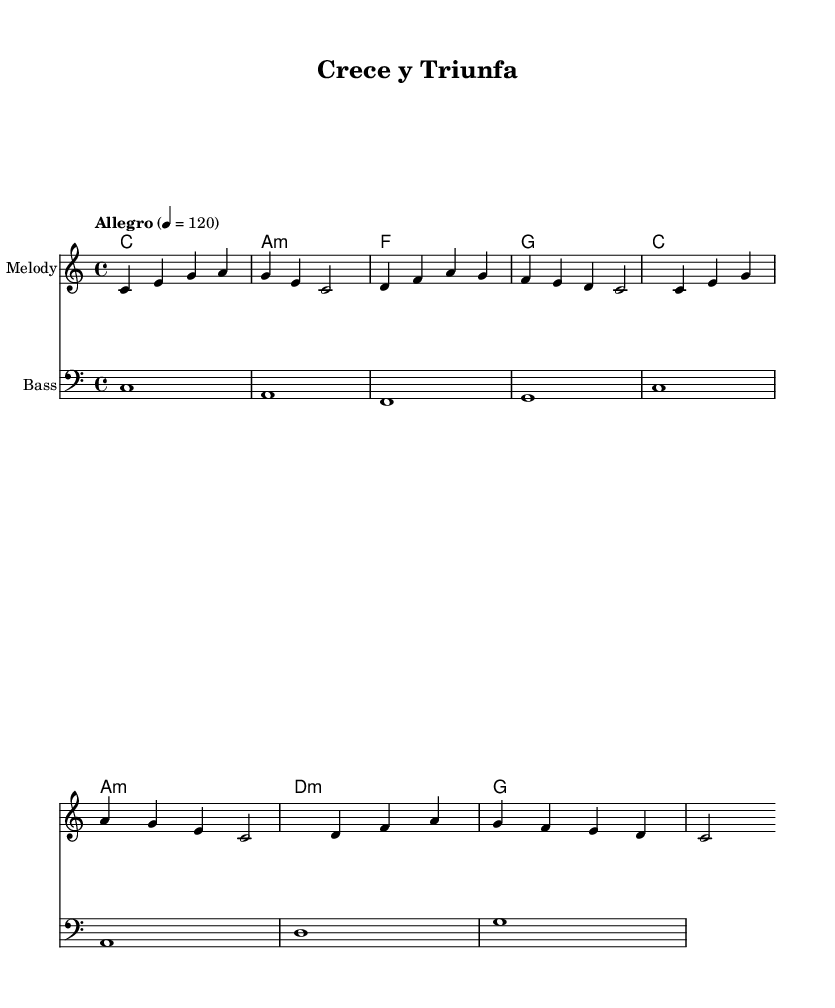What is the key signature of this music? The key signature is C major, which has no sharps or flats.
Answer: C major What is the time signature of this music? The time signature is indicated as 4/4, meaning there are four beats in each measure.
Answer: 4/4 What is the tempo marking for this piece? The tempo marking shows "Allegro" with a metronome mark of 120, indicating a fast tempo.
Answer: Allegro 120 How many measures does the melody have? The melody consists of 8 measures, as seen in the repeated sections.
Answer: 8 What is the last chord in the harmony section? The last chord shown in the harmonies is G, which is the final chord in the sequence.
Answer: G What theme does the lyrics convey? The lyrics focus on personal growth and determination, explicitly stating that success is in your hands and emphasizing perseverance.
Answer: Personal growth How is the structure of this piece typical for Latin pop? The piece features repetitive melodies and uplifting lyrics, common traits in Latin pop that enhance the motivational theme.
Answer: Repetitive melodies and uplifting lyrics 